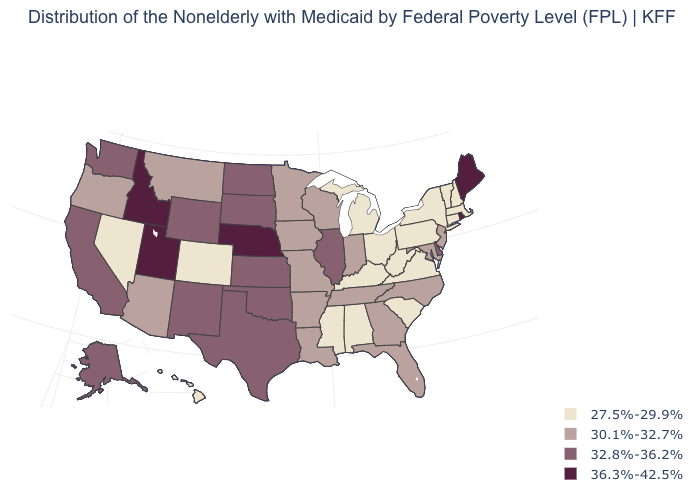What is the value of Hawaii?
Be succinct. 27.5%-29.9%. Is the legend a continuous bar?
Short answer required. No. Is the legend a continuous bar?
Give a very brief answer. No. What is the value of Indiana?
Give a very brief answer. 30.1%-32.7%. What is the value of Iowa?
Quick response, please. 30.1%-32.7%. Which states hav the highest value in the Northeast?
Quick response, please. Maine, Rhode Island. Name the states that have a value in the range 30.1%-32.7%?
Answer briefly. Arizona, Arkansas, Florida, Georgia, Indiana, Iowa, Louisiana, Maryland, Minnesota, Missouri, Montana, New Jersey, North Carolina, Oregon, Tennessee, Wisconsin. Does New Jersey have the same value as Illinois?
Answer briefly. No. Does Maine have the highest value in the USA?
Answer briefly. Yes. Among the states that border Connecticut , does Massachusetts have the highest value?
Give a very brief answer. No. Does the first symbol in the legend represent the smallest category?
Write a very short answer. Yes. Name the states that have a value in the range 27.5%-29.9%?
Keep it brief. Alabama, Colorado, Connecticut, Hawaii, Kentucky, Massachusetts, Michigan, Mississippi, Nevada, New Hampshire, New York, Ohio, Pennsylvania, South Carolina, Vermont, Virginia, West Virginia. Name the states that have a value in the range 30.1%-32.7%?
Short answer required. Arizona, Arkansas, Florida, Georgia, Indiana, Iowa, Louisiana, Maryland, Minnesota, Missouri, Montana, New Jersey, North Carolina, Oregon, Tennessee, Wisconsin. What is the value of North Dakota?
Write a very short answer. 32.8%-36.2%. Does the map have missing data?
Give a very brief answer. No. 